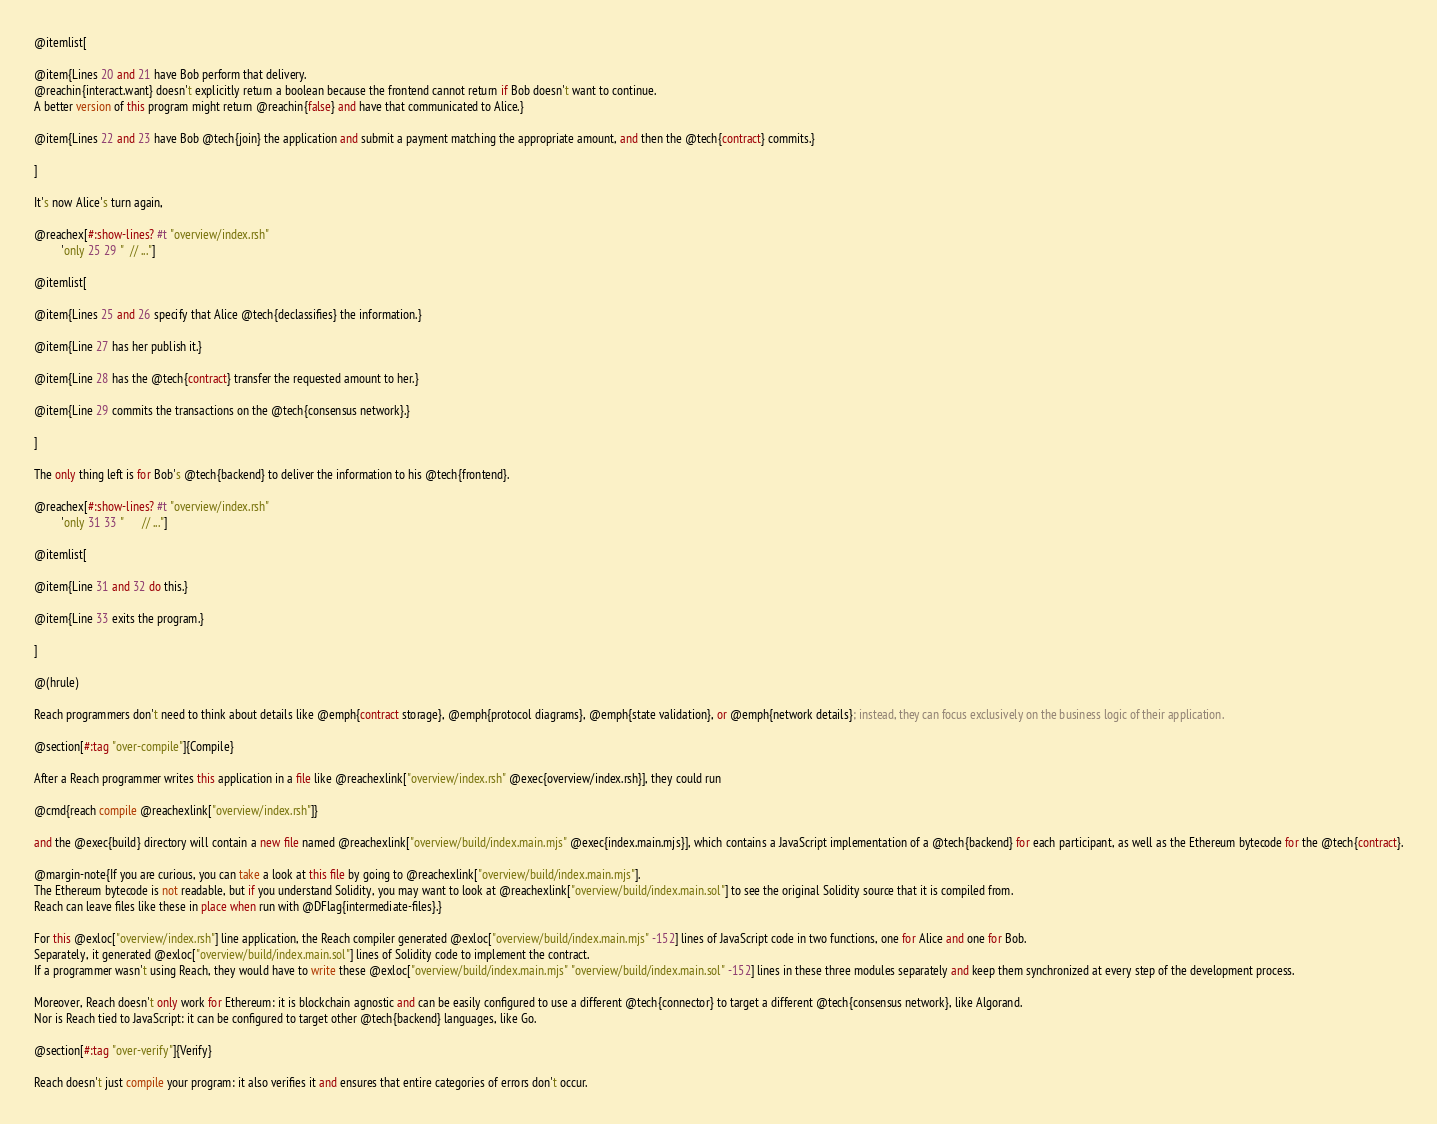Convert code to text. <code><loc_0><loc_0><loc_500><loc_500><_Racket_>
@itemlist[

@item{Lines 20 and 21 have Bob perform that delivery.
@reachin{interact.want} doesn't explicitly return a boolean because the frontend cannot return if Bob doesn't want to continue.
A better version of this program might return @reachin{false} and have that communicated to Alice.}

@item{Lines 22 and 23 have Bob @tech{join} the application and submit a payment matching the appropriate amount, and then the @tech{contract} commits.}

]

It's now Alice's turn again,

@reachex[#:show-lines? #t "overview/index.rsh"
         'only 25 29 "  // ..."]

@itemlist[

@item{Lines 25 and 26 specify that Alice @tech{declassifies} the information.}

@item{Line 27 has her publish it.}

@item{Line 28 has the @tech{contract} transfer the requested amount to her.}

@item{Line 29 commits the transactions on the @tech{consensus network}.}

]

The only thing left is for Bob's @tech{backend} to deliver the information to his @tech{frontend}.

@reachex[#:show-lines? #t "overview/index.rsh"
         'only 31 33 "      // ..."]

@itemlist[

@item{Line 31 and 32 do this.}

@item{Line 33 exits the program.}

]

@(hrule)

Reach programmers don't need to think about details like @emph{contract storage}, @emph{protocol diagrams}, @emph{state validation}, or @emph{network details}; instead, they can focus exclusively on the business logic of their application.

@section[#:tag "over-compile"]{Compile}

After a Reach programmer writes this application in a file like @reachexlink["overview/index.rsh" @exec{overview/index.rsh}], they could run

@cmd{reach compile @reachexlink["overview/index.rsh"]}

and the @exec{build} directory will contain a new file named @reachexlink["overview/build/index.main.mjs" @exec{index.main.mjs}], which contains a JavaScript implementation of a @tech{backend} for each participant, as well as the Ethereum bytecode for the @tech{contract}.

@margin-note{If you are curious, you can take a look at this file by going to @reachexlink["overview/build/index.main.mjs"].
The Ethereum bytecode is not readable, but if you understand Solidity, you may want to look at @reachexlink["overview/build/index.main.sol"] to see the original Solidity source that it is compiled from.
Reach can leave files like these in place when run with @DFlag{intermediate-files}.}

For this @exloc["overview/index.rsh"] line application, the Reach compiler generated @exloc["overview/build/index.main.mjs" -152] lines of JavaScript code in two functions, one for Alice and one for Bob.
Separately, it generated @exloc["overview/build/index.main.sol"] lines of Solidity code to implement the contract.
If a programmer wasn't using Reach, they would have to write these @exloc["overview/build/index.main.mjs" "overview/build/index.main.sol" -152] lines in these three modules separately and keep them synchronized at every step of the development process.

Moreover, Reach doesn't only work for Ethereum: it is blockchain agnostic and can be easily configured to use a different @tech{connector} to target a different @tech{consensus network}, like Algorand.
Nor is Reach tied to JavaScript: it can be configured to target other @tech{backend} languages, like Go.

@section[#:tag "over-verify"]{Verify}

Reach doesn't just compile your program: it also verifies it and ensures that entire categories of errors don't occur.</code> 